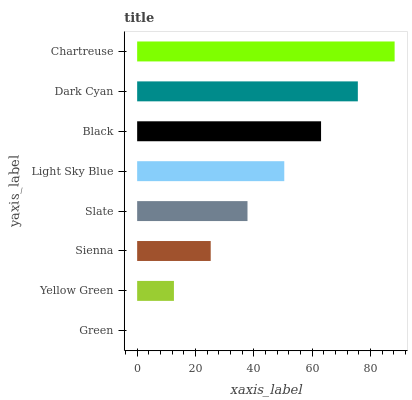Is Green the minimum?
Answer yes or no. Yes. Is Chartreuse the maximum?
Answer yes or no. Yes. Is Yellow Green the minimum?
Answer yes or no. No. Is Yellow Green the maximum?
Answer yes or no. No. Is Yellow Green greater than Green?
Answer yes or no. Yes. Is Green less than Yellow Green?
Answer yes or no. Yes. Is Green greater than Yellow Green?
Answer yes or no. No. Is Yellow Green less than Green?
Answer yes or no. No. Is Light Sky Blue the high median?
Answer yes or no. Yes. Is Slate the low median?
Answer yes or no. Yes. Is Dark Cyan the high median?
Answer yes or no. No. Is Green the low median?
Answer yes or no. No. 